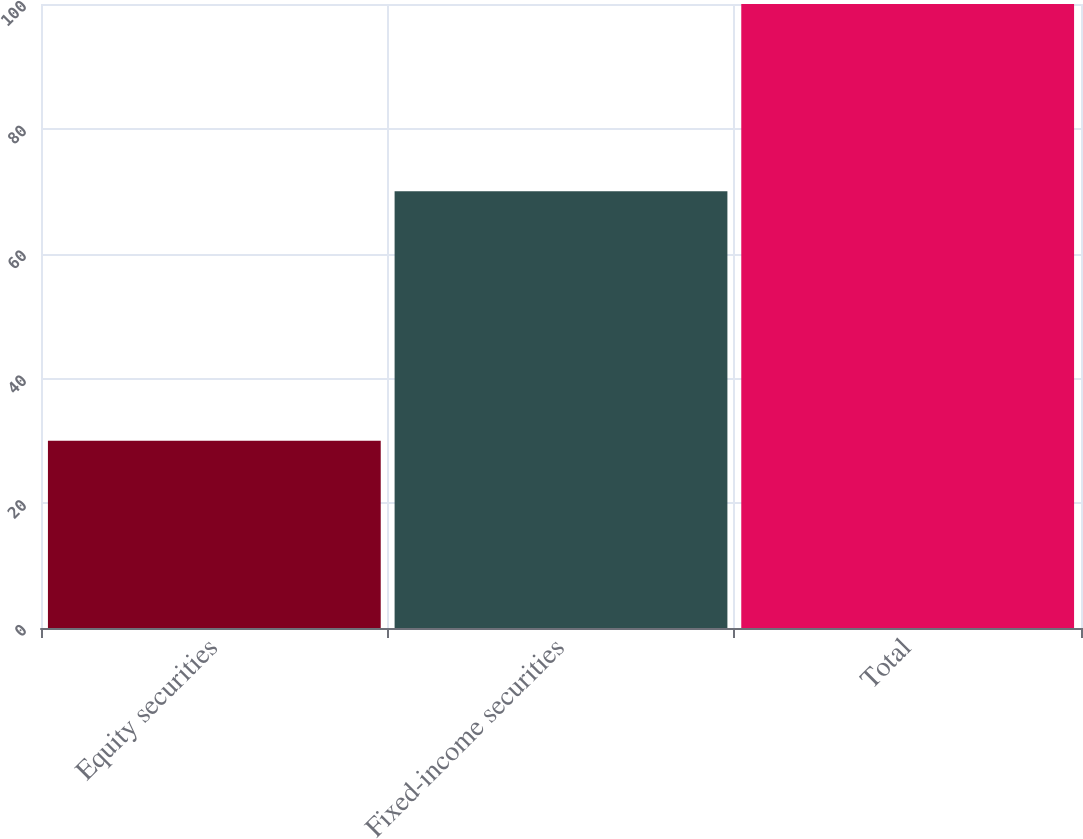Convert chart to OTSL. <chart><loc_0><loc_0><loc_500><loc_500><bar_chart><fcel>Equity securities<fcel>Fixed-income securities<fcel>Total<nl><fcel>30<fcel>70<fcel>100<nl></chart> 